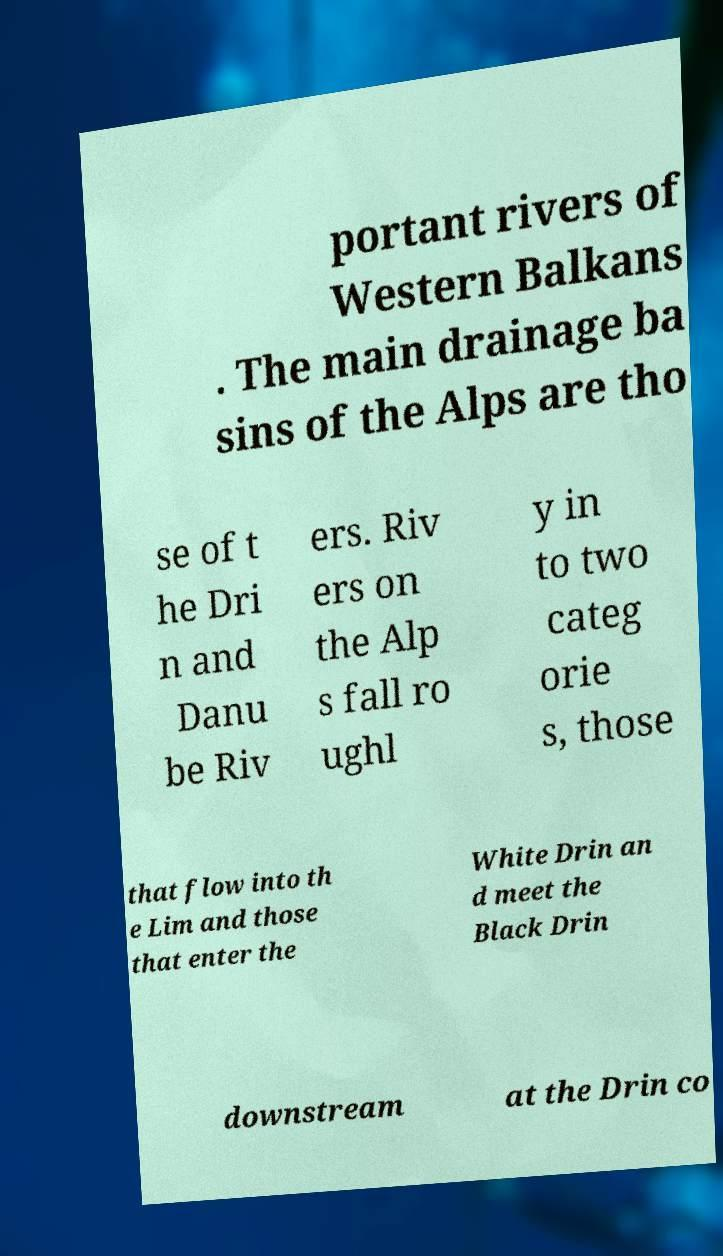Please identify and transcribe the text found in this image. portant rivers of Western Balkans . The main drainage ba sins of the Alps are tho se of t he Dri n and Danu be Riv ers. Riv ers on the Alp s fall ro ughl y in to two categ orie s, those that flow into th e Lim and those that enter the White Drin an d meet the Black Drin downstream at the Drin co 